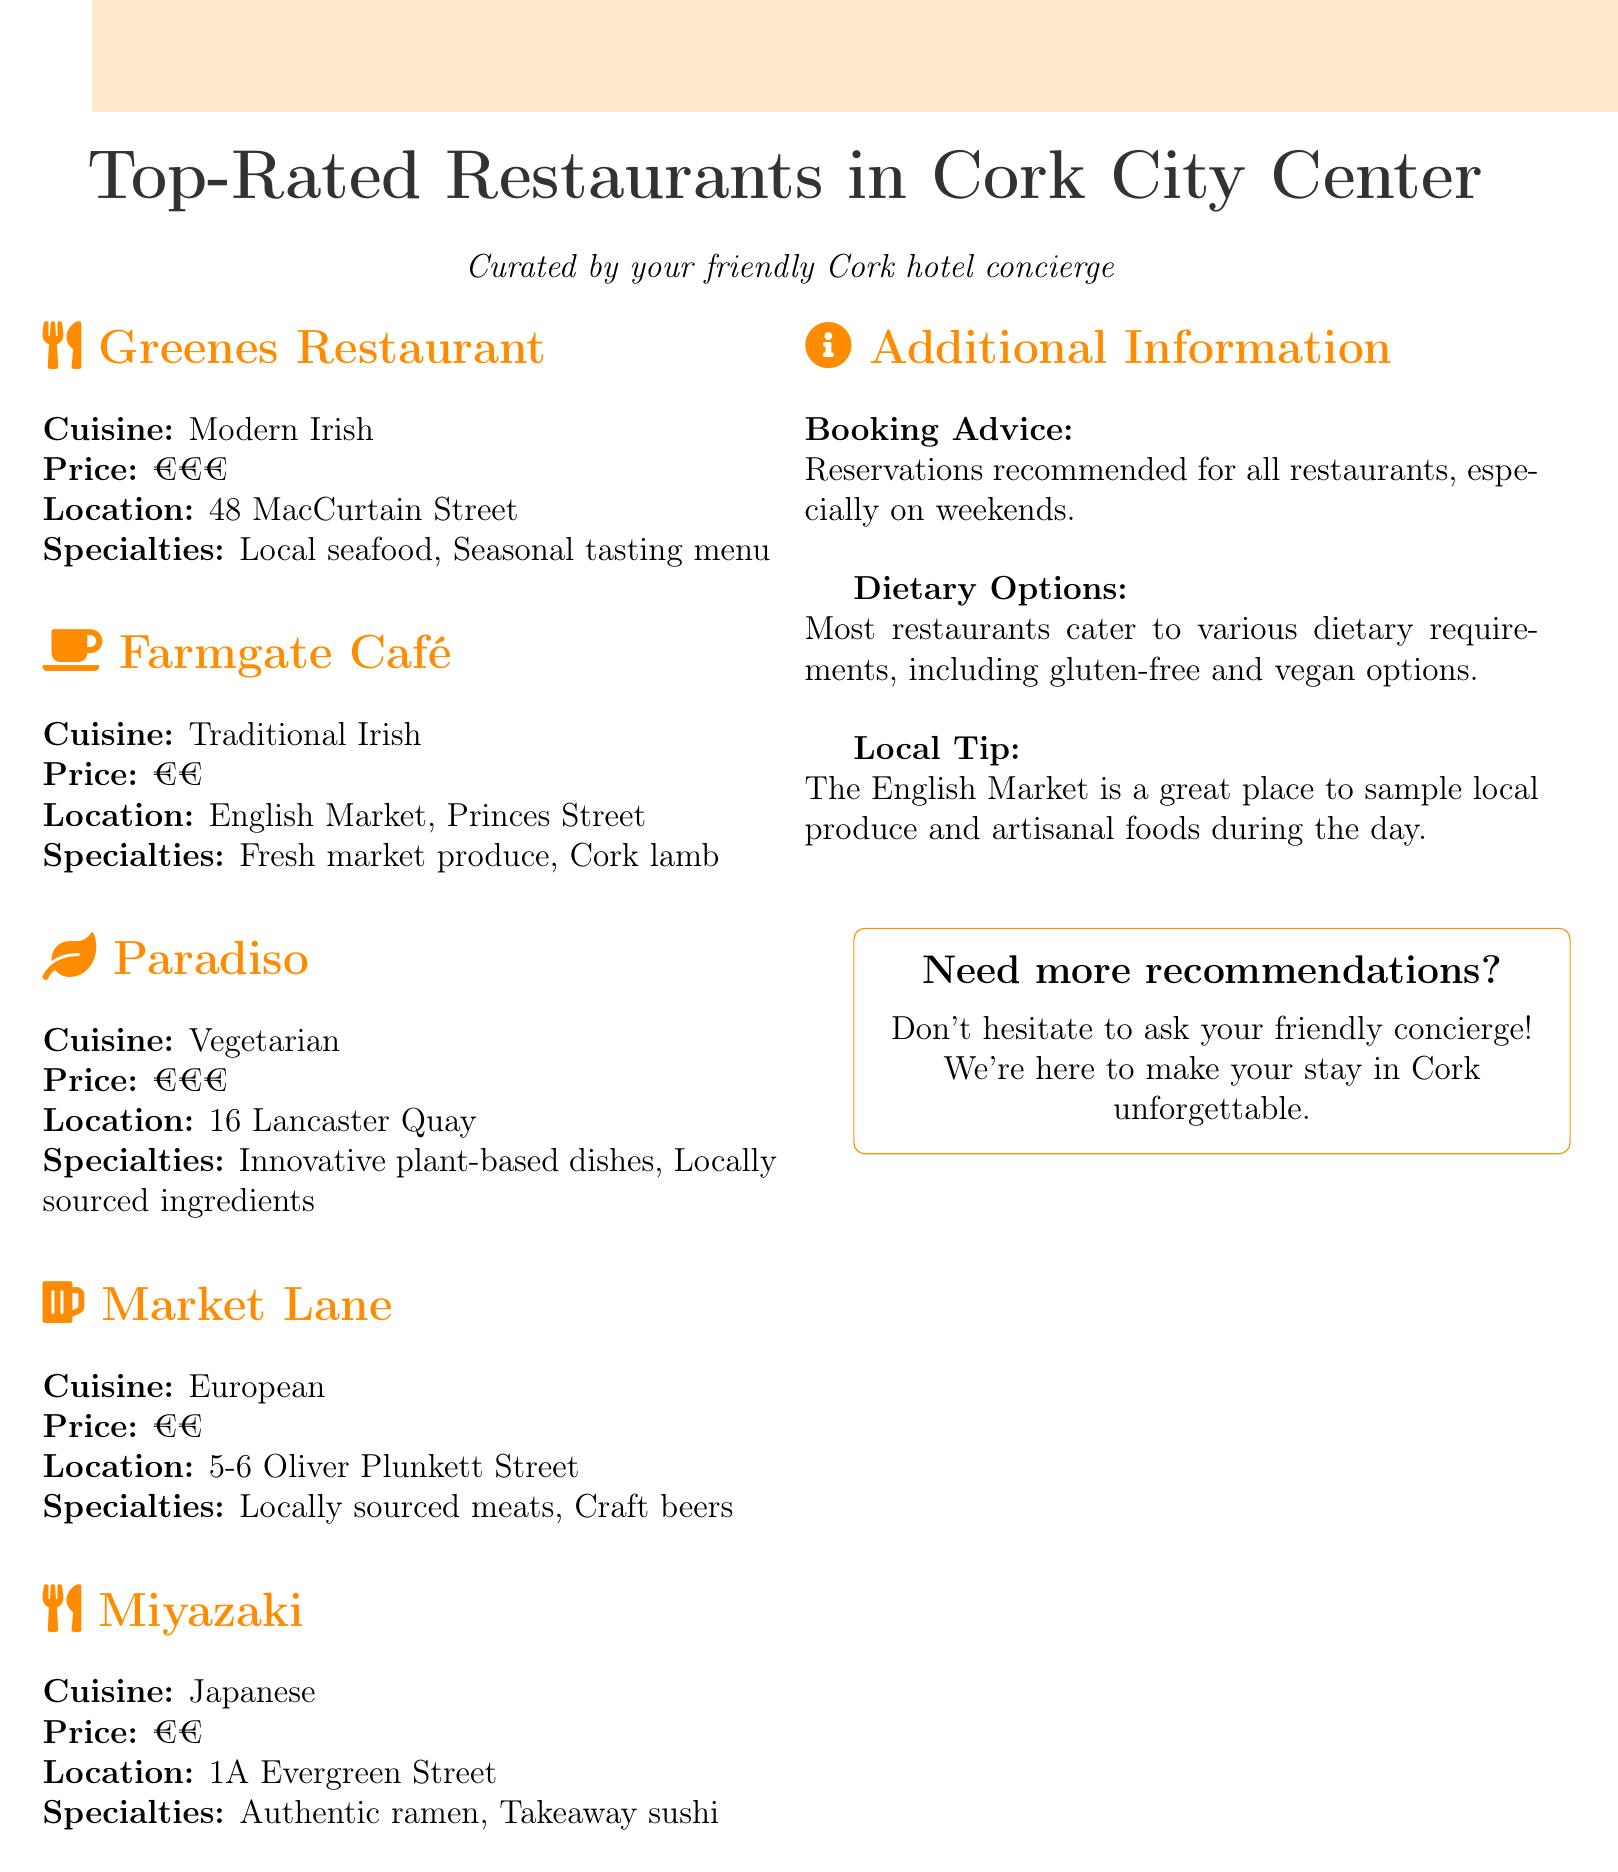What is the name of a restaurant offering Modern Irish cuisine? The document lists Greenes Restaurant as a Modern Irish cuisine option.
Answer: Greenes Restaurant What is the price range for Farmgate Café? The document specifies that Farmgate Café has a price range of €€.
Answer: €€ Where is Paradiso located? The location of Paradiso is mentioned in the document as 16 Lancaster Quay.
Answer: 16 Lancaster Quay Which restaurant specializes in vegan options? The document states that most restaurants cater to various dietary requirements, including vegan options.
Answer: Most restaurants What type of cuisine does Miyazaki serve? The document clearly indicates that Miyazaki serves Japanese cuisine.
Answer: Japanese Which restaurant has a specialty in seasonal tasting menu? Greenes Restaurant is noted for its specialty in a seasonal tasting menu.
Answer: Greenes Restaurant What advice is given regarding reservations? The document advises that reservations are recommended for all restaurants, especially on weekends.
Answer: Reservations recommended What local tip is mentioned in relation to the English Market? The document suggests the English Market is a great place to sample local produce and artisanal foods.
Answer: Sample local produce What is the specialty of Market Lane? The document mentions that Market Lane specializes in locally sourced meats and craft beers.
Answer: Locally sourced meats, craft beers 